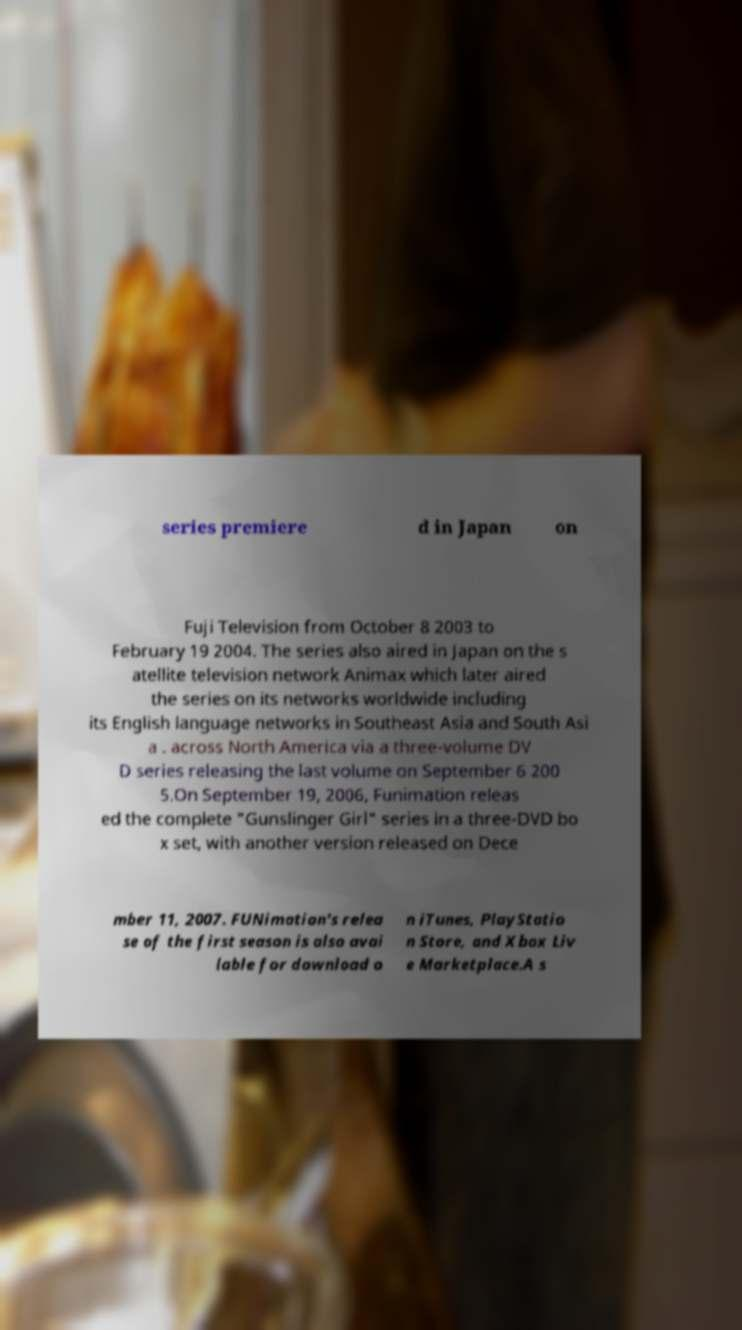What messages or text are displayed in this image? I need them in a readable, typed format. series premiere d in Japan on Fuji Television from October 8 2003 to February 19 2004. The series also aired in Japan on the s atellite television network Animax which later aired the series on its networks worldwide including its English language networks in Southeast Asia and South Asi a . across North America via a three-volume DV D series releasing the last volume on September 6 200 5.On September 19, 2006, Funimation releas ed the complete "Gunslinger Girl" series in a three-DVD bo x set, with another version released on Dece mber 11, 2007. FUNimation's relea se of the first season is also avai lable for download o n iTunes, PlayStatio n Store, and Xbox Liv e Marketplace.A s 